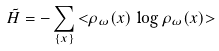Convert formula to latex. <formula><loc_0><loc_0><loc_500><loc_500>\tilde { H } = - \sum _ { \{ x \} } { < } \rho _ { \omega } ( x ) \, \log \rho _ { \omega } ( x ) { > }</formula> 